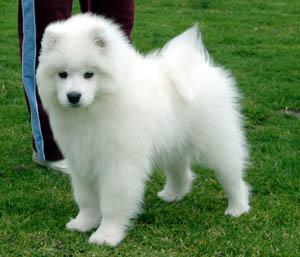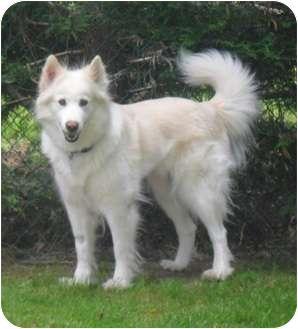The first image is the image on the left, the second image is the image on the right. Assess this claim about the two images: "At least one dog is lying down in the image on the left.". Correct or not? Answer yes or no. No. The first image is the image on the left, the second image is the image on the right. Evaluate the accuracy of this statement regarding the images: "All dogs face the same direction, and all dogs are standing on all fours.". Is it true? Answer yes or no. Yes. 